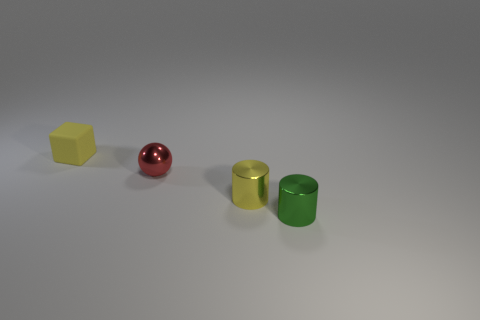There is a object that is the same color as the tiny matte cube; what size is it?
Offer a terse response. Small. There is a cylinder behind the metal cylinder that is in front of the yellow metal cylinder; is there a tiny cylinder behind it?
Your answer should be compact. No. There is a red object; are there any small cylinders to the right of it?
Make the answer very short. Yes. There is a yellow thing that is on the right side of the tiny rubber block; how many objects are in front of it?
Your answer should be compact. 1. Does the yellow matte thing have the same size as the yellow object in front of the rubber thing?
Your answer should be very brief. Yes. Are there any tiny shiny spheres that have the same color as the small rubber object?
Provide a succinct answer. No. There is a green cylinder that is made of the same material as the red ball; what size is it?
Your answer should be compact. Small. Is the material of the green cylinder the same as the cube?
Give a very brief answer. No. What is the color of the thing that is to the right of the yellow thing that is on the right side of the yellow object behind the red object?
Offer a terse response. Green. The small yellow matte thing is what shape?
Offer a terse response. Cube. 